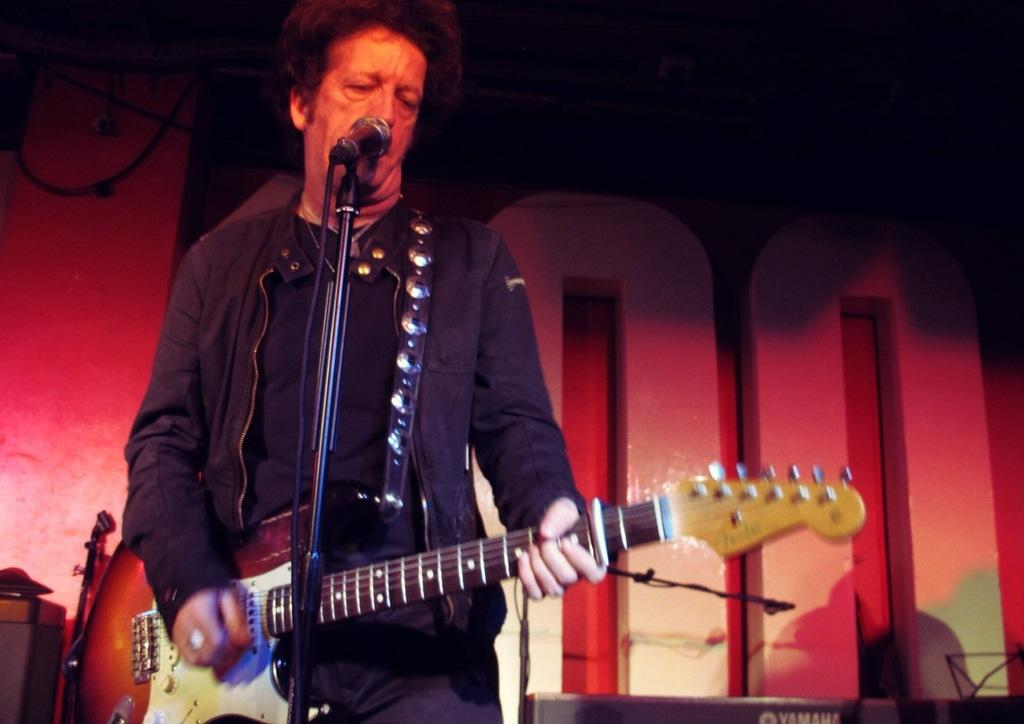Who is the main subject in the image? There is a man in the image. What is the man wearing? The man is wearing a black jacket. What is the man holding in the image? The man is holding a guitar. What is the man doing in the image? The man is singing a song. What is in front of the man for amplifying his voice? There is a microphone with a stand in front of the man. What can be seen behind the man in the image? The background of the image is a wall. How many ants can be seen crawling on the man's guitar in the image? There are no ants present in the image, so it is not possible to determine how many would be crawling on the guitar. 